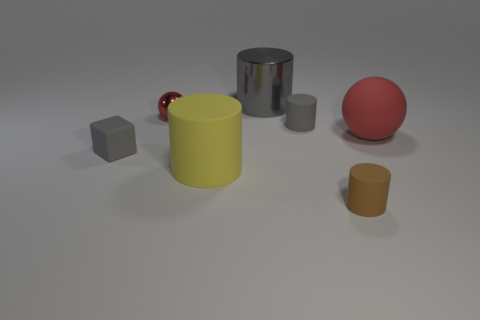Is the shape of the large gray metallic object the same as the yellow thing to the right of the cube?
Give a very brief answer. Yes. Is there a brown object that has the same material as the big gray cylinder?
Ensure brevity in your answer.  No. Are there any large yellow things that are behind the cylinder that is left of the large metal thing behind the tiny red sphere?
Offer a very short reply. No. How many other things are there of the same shape as the big shiny thing?
Ensure brevity in your answer.  3. What is the color of the rubber cylinder left of the gray cylinder that is on the left side of the small cylinder that is behind the large ball?
Provide a succinct answer. Yellow. What number of big red shiny objects are there?
Ensure brevity in your answer.  0. What number of tiny things are cyan metallic cylinders or balls?
Make the answer very short. 1. The gray metallic thing that is the same size as the yellow rubber cylinder is what shape?
Offer a very short reply. Cylinder. Is there anything else that is the same size as the red shiny ball?
Offer a very short reply. Yes. What material is the red sphere that is left of the big matte object in front of the tiny gray matte cube?
Provide a succinct answer. Metal. 